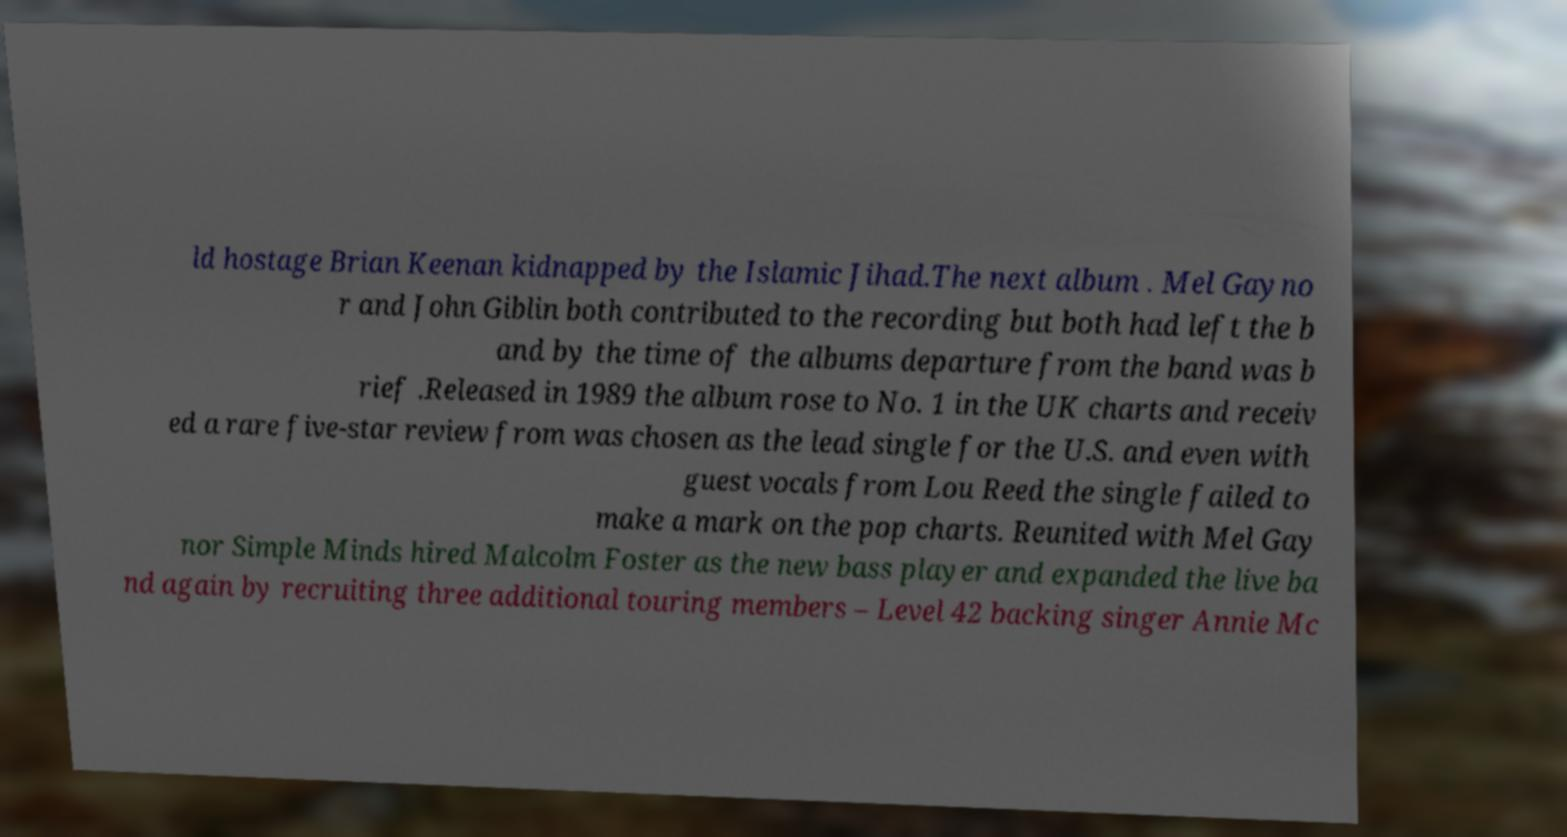Can you read and provide the text displayed in the image?This photo seems to have some interesting text. Can you extract and type it out for me? ld hostage Brian Keenan kidnapped by the Islamic Jihad.The next album . Mel Gayno r and John Giblin both contributed to the recording but both had left the b and by the time of the albums departure from the band was b rief .Released in 1989 the album rose to No. 1 in the UK charts and receiv ed a rare five-star review from was chosen as the lead single for the U.S. and even with guest vocals from Lou Reed the single failed to make a mark on the pop charts. Reunited with Mel Gay nor Simple Minds hired Malcolm Foster as the new bass player and expanded the live ba nd again by recruiting three additional touring members – Level 42 backing singer Annie Mc 